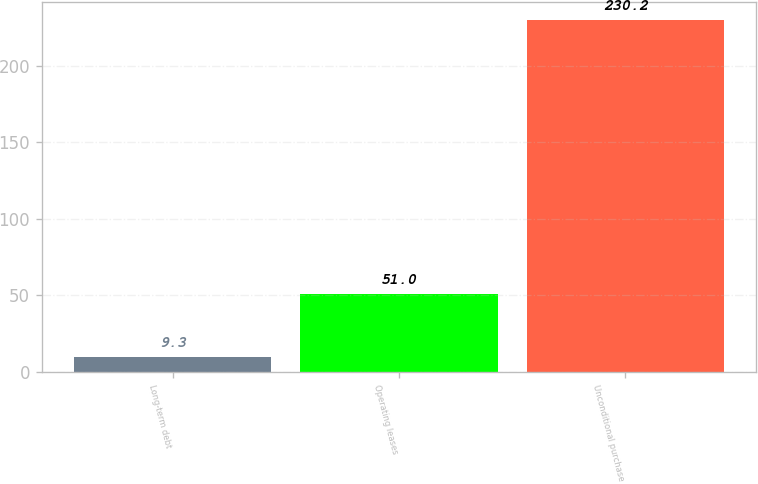Convert chart to OTSL. <chart><loc_0><loc_0><loc_500><loc_500><bar_chart><fcel>Long-term debt<fcel>Operating leases<fcel>Unconditional purchase<nl><fcel>9.3<fcel>51<fcel>230.2<nl></chart> 